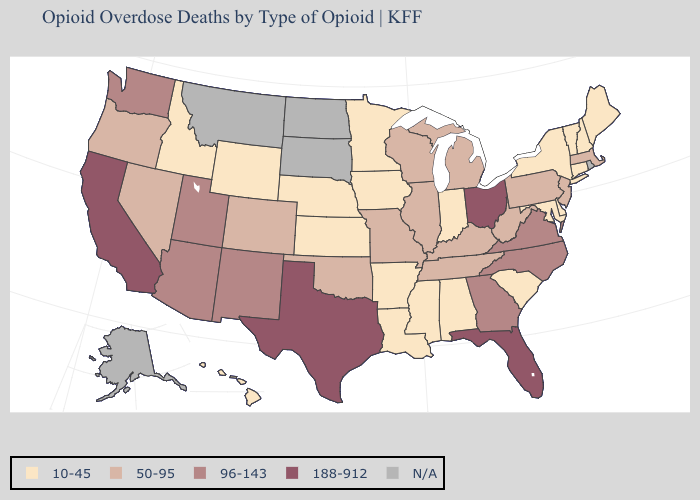Is the legend a continuous bar?
Quick response, please. No. Name the states that have a value in the range 50-95?
Quick response, please. Colorado, Illinois, Kentucky, Massachusetts, Michigan, Missouri, Nevada, New Jersey, Oklahoma, Oregon, Pennsylvania, Tennessee, West Virginia, Wisconsin. Name the states that have a value in the range N/A?
Quick response, please. Alaska, Montana, North Dakota, Rhode Island, South Dakota. What is the value of Wyoming?
Give a very brief answer. 10-45. Name the states that have a value in the range 188-912?
Short answer required. California, Florida, Ohio, Texas. What is the highest value in states that border Texas?
Answer briefly. 96-143. Among the states that border Georgia , does Alabama have the lowest value?
Keep it brief. Yes. Does Tennessee have the lowest value in the South?
Give a very brief answer. No. Among the states that border South Dakota , which have the highest value?
Answer briefly. Iowa, Minnesota, Nebraska, Wyoming. What is the value of West Virginia?
Keep it brief. 50-95. How many symbols are there in the legend?
Quick response, please. 5. Among the states that border Delaware , which have the highest value?
Short answer required. New Jersey, Pennsylvania. Among the states that border Wisconsin , does Minnesota have the lowest value?
Short answer required. Yes. What is the highest value in states that border Wisconsin?
Short answer required. 50-95. 